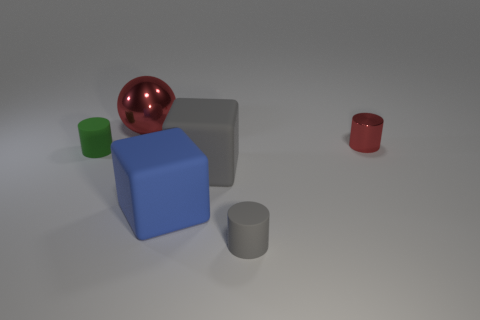Comparing the sizes of the objects, can you estimate their relative distances from each other? Assuming the objects have consistent sizes in reality, the blue cube appears to be the closest, as it is the largest and most central object. The green cube is slightly smaller and offset, possibly a short distance behind the blue cube. The grey objects are further away based on their size and positioning. Finally, the red cylinder, being the smallest in appearance, is likely the furthest from the viewpoint. 